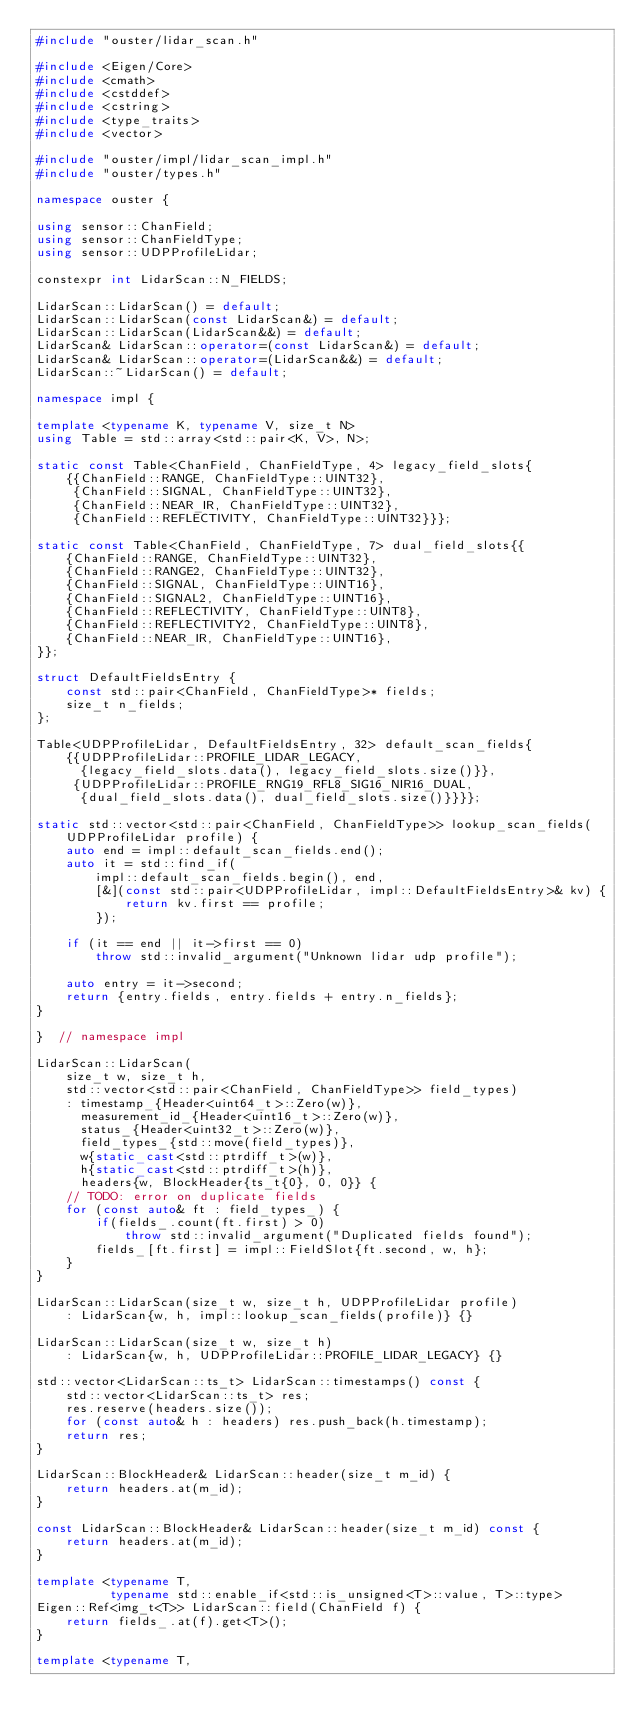<code> <loc_0><loc_0><loc_500><loc_500><_C++_>#include "ouster/lidar_scan.h"

#include <Eigen/Core>
#include <cmath>
#include <cstddef>
#include <cstring>
#include <type_traits>
#include <vector>

#include "ouster/impl/lidar_scan_impl.h"
#include "ouster/types.h"

namespace ouster {

using sensor::ChanField;
using sensor::ChanFieldType;
using sensor::UDPProfileLidar;

constexpr int LidarScan::N_FIELDS;

LidarScan::LidarScan() = default;
LidarScan::LidarScan(const LidarScan&) = default;
LidarScan::LidarScan(LidarScan&&) = default;
LidarScan& LidarScan::operator=(const LidarScan&) = default;
LidarScan& LidarScan::operator=(LidarScan&&) = default;
LidarScan::~LidarScan() = default;

namespace impl {

template <typename K, typename V, size_t N>
using Table = std::array<std::pair<K, V>, N>;

static const Table<ChanField, ChanFieldType, 4> legacy_field_slots{
    {{ChanField::RANGE, ChanFieldType::UINT32},
     {ChanField::SIGNAL, ChanFieldType::UINT32},
     {ChanField::NEAR_IR, ChanFieldType::UINT32},
     {ChanField::REFLECTIVITY, ChanFieldType::UINT32}}};

static const Table<ChanField, ChanFieldType, 7> dual_field_slots{{
    {ChanField::RANGE, ChanFieldType::UINT32},
    {ChanField::RANGE2, ChanFieldType::UINT32},
    {ChanField::SIGNAL, ChanFieldType::UINT16},
    {ChanField::SIGNAL2, ChanFieldType::UINT16},
    {ChanField::REFLECTIVITY, ChanFieldType::UINT8},
    {ChanField::REFLECTIVITY2, ChanFieldType::UINT8},
    {ChanField::NEAR_IR, ChanFieldType::UINT16},
}};

struct DefaultFieldsEntry {
    const std::pair<ChanField, ChanFieldType>* fields;
    size_t n_fields;
};

Table<UDPProfileLidar, DefaultFieldsEntry, 32> default_scan_fields{
    {{UDPProfileLidar::PROFILE_LIDAR_LEGACY,
      {legacy_field_slots.data(), legacy_field_slots.size()}},
     {UDPProfileLidar::PROFILE_RNG19_RFL8_SIG16_NIR16_DUAL,
      {dual_field_slots.data(), dual_field_slots.size()}}}};

static std::vector<std::pair<ChanField, ChanFieldType>> lookup_scan_fields(
    UDPProfileLidar profile) {
    auto end = impl::default_scan_fields.end();
    auto it = std::find_if(
        impl::default_scan_fields.begin(), end,
        [&](const std::pair<UDPProfileLidar, impl::DefaultFieldsEntry>& kv) {
            return kv.first == profile;
        });

    if (it == end || it->first == 0)
        throw std::invalid_argument("Unknown lidar udp profile");

    auto entry = it->second;
    return {entry.fields, entry.fields + entry.n_fields};
}

}  // namespace impl

LidarScan::LidarScan(
    size_t w, size_t h,
    std::vector<std::pair<ChanField, ChanFieldType>> field_types)
    : timestamp_{Header<uint64_t>::Zero(w)},
      measurement_id_{Header<uint16_t>::Zero(w)},
      status_{Header<uint32_t>::Zero(w)},
      field_types_{std::move(field_types)},
      w{static_cast<std::ptrdiff_t>(w)},
      h{static_cast<std::ptrdiff_t>(h)},
      headers{w, BlockHeader{ts_t{0}, 0, 0}} {
    // TODO: error on duplicate fields
    for (const auto& ft : field_types_) {
        if(fields_.count(ft.first) > 0)
            throw std::invalid_argument("Duplicated fields found");
        fields_[ft.first] = impl::FieldSlot{ft.second, w, h};
    }
}

LidarScan::LidarScan(size_t w, size_t h, UDPProfileLidar profile)
    : LidarScan{w, h, impl::lookup_scan_fields(profile)} {}

LidarScan::LidarScan(size_t w, size_t h)
    : LidarScan{w, h, UDPProfileLidar::PROFILE_LIDAR_LEGACY} {}

std::vector<LidarScan::ts_t> LidarScan::timestamps() const {
    std::vector<LidarScan::ts_t> res;
    res.reserve(headers.size());
    for (const auto& h : headers) res.push_back(h.timestamp);
    return res;
}

LidarScan::BlockHeader& LidarScan::header(size_t m_id) {
    return headers.at(m_id);
}

const LidarScan::BlockHeader& LidarScan::header(size_t m_id) const {
    return headers.at(m_id);
}

template <typename T,
          typename std::enable_if<std::is_unsigned<T>::value, T>::type>
Eigen::Ref<img_t<T>> LidarScan::field(ChanField f) {
    return fields_.at(f).get<T>();
}

template <typename T,</code> 